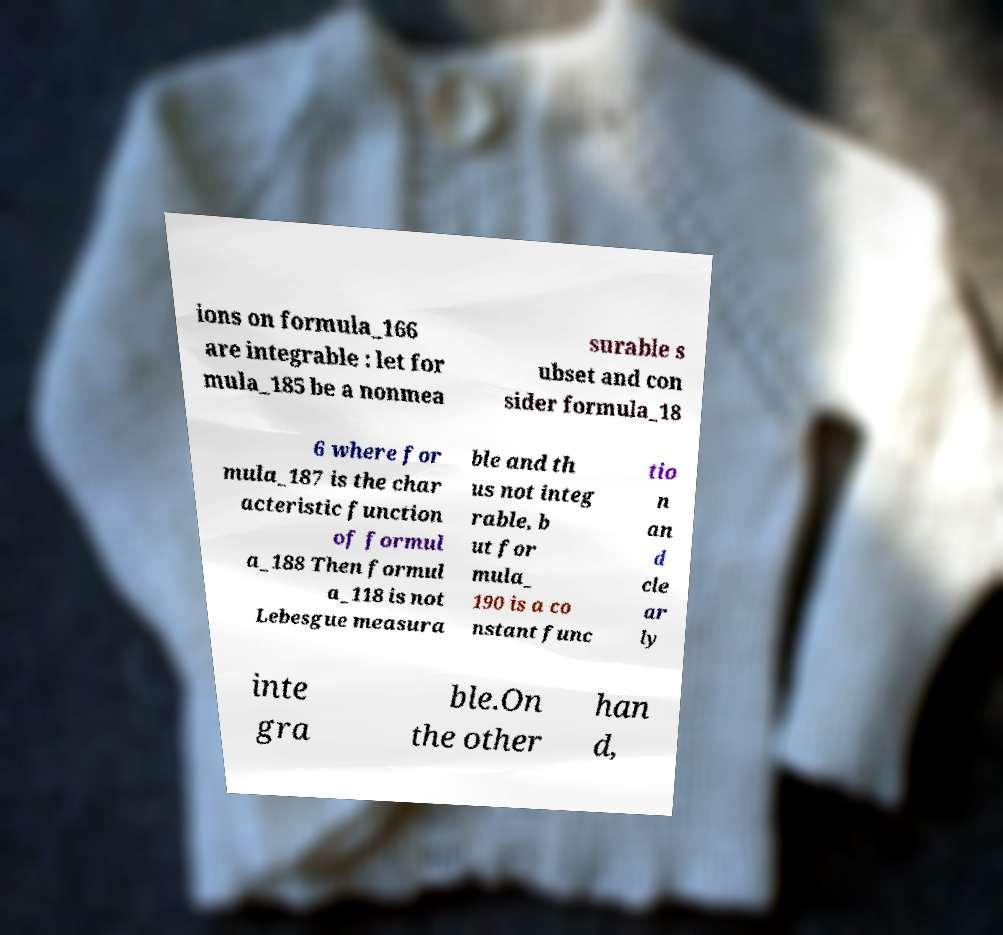Could you extract and type out the text from this image? ions on formula_166 are integrable : let for mula_185 be a nonmea surable s ubset and con sider formula_18 6 where for mula_187 is the char acteristic function of formul a_188 Then formul a_118 is not Lebesgue measura ble and th us not integ rable, b ut for mula_ 190 is a co nstant func tio n an d cle ar ly inte gra ble.On the other han d, 